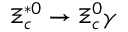Convert formula to latex. <formula><loc_0><loc_0><loc_500><loc_500>\Xi _ { c } ^ { * 0 } \to \Xi _ { c } ^ { 0 } \gamma</formula> 